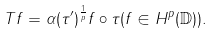<formula> <loc_0><loc_0><loc_500><loc_500>T f = \alpha ( \tau ^ { \prime } ) ^ { \frac { 1 } { p } } f \circ \tau ( f \in H ^ { p } ( { \mathbb { D } } ) ) .</formula> 